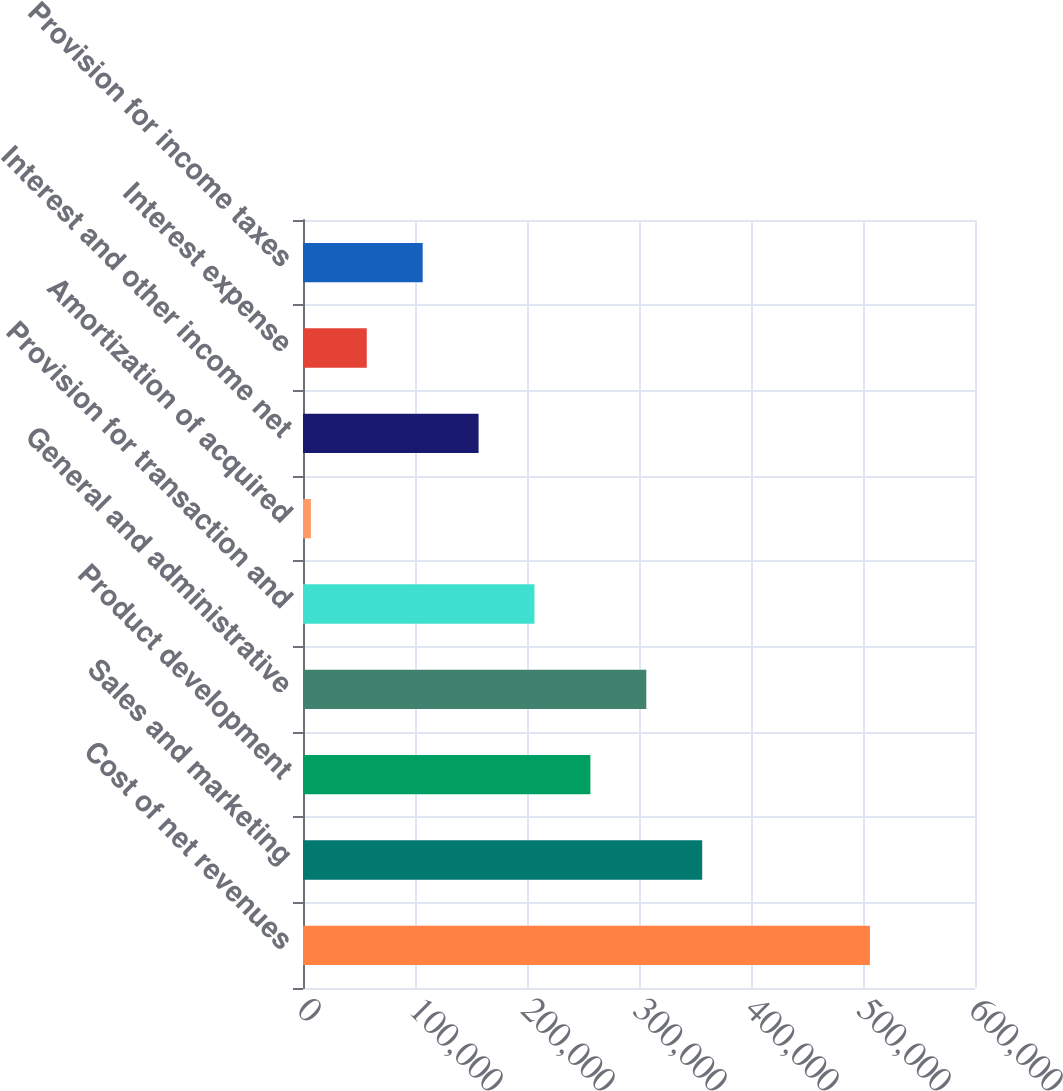Convert chart to OTSL. <chart><loc_0><loc_0><loc_500><loc_500><bar_chart><fcel>Cost of net revenues<fcel>Sales and marketing<fcel>Product development<fcel>General and administrative<fcel>Provision for transaction and<fcel>Amortization of acquired<fcel>Interest and other income net<fcel>Interest expense<fcel>Provision for income taxes<nl><fcel>506180<fcel>356434<fcel>256603<fcel>306518<fcel>206688<fcel>7026<fcel>156772<fcel>56941.4<fcel>106857<nl></chart> 